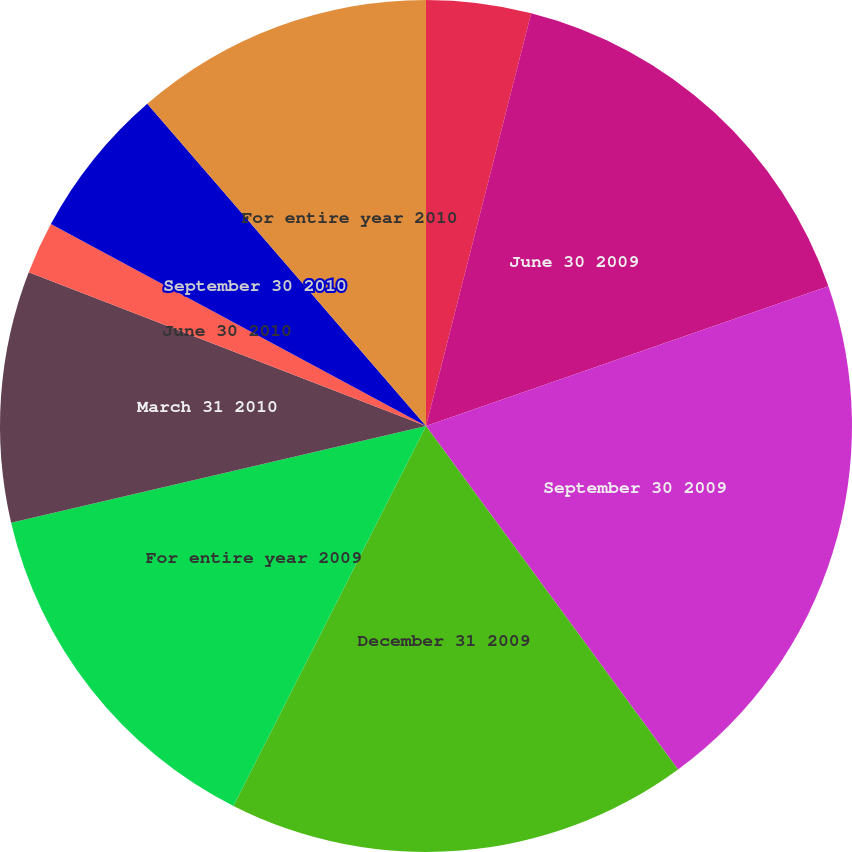Convert chart to OTSL. <chart><loc_0><loc_0><loc_500><loc_500><pie_chart><fcel>March 31 2009<fcel>June 30 2009<fcel>September 30 2009<fcel>December 31 2009<fcel>For entire year 2009<fcel>March 31 2010<fcel>June 30 2010<fcel>September 30 2010<fcel>For entire year 2010<nl><fcel>3.97%<fcel>15.71%<fcel>20.24%<fcel>17.54%<fcel>13.89%<fcel>9.52%<fcel>1.98%<fcel>5.79%<fcel>11.35%<nl></chart> 